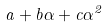<formula> <loc_0><loc_0><loc_500><loc_500>a + b \alpha + c \alpha ^ { 2 }</formula> 